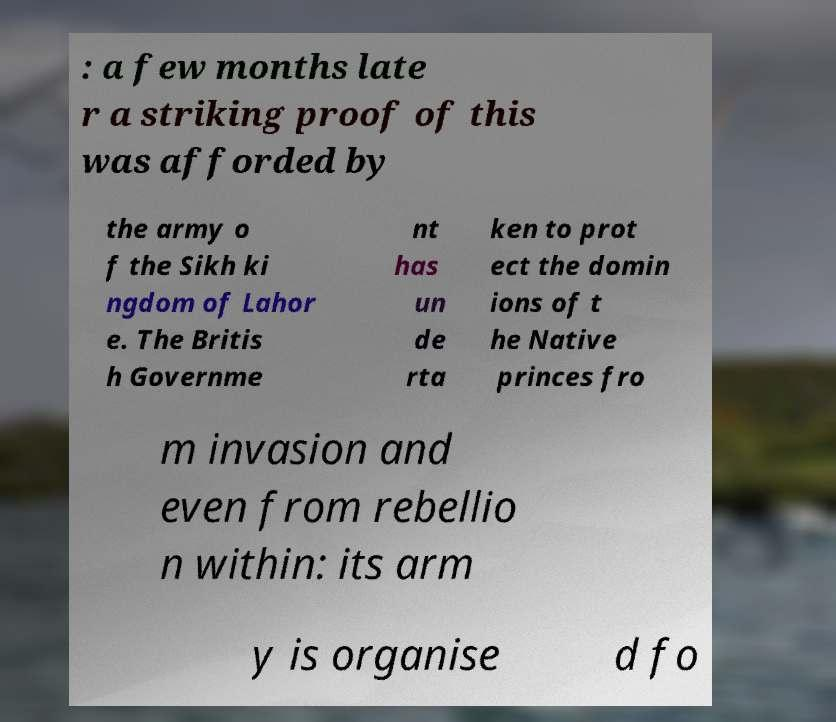For documentation purposes, I need the text within this image transcribed. Could you provide that? : a few months late r a striking proof of this was afforded by the army o f the Sikh ki ngdom of Lahor e. The Britis h Governme nt has un de rta ken to prot ect the domin ions of t he Native princes fro m invasion and even from rebellio n within: its arm y is organise d fo 